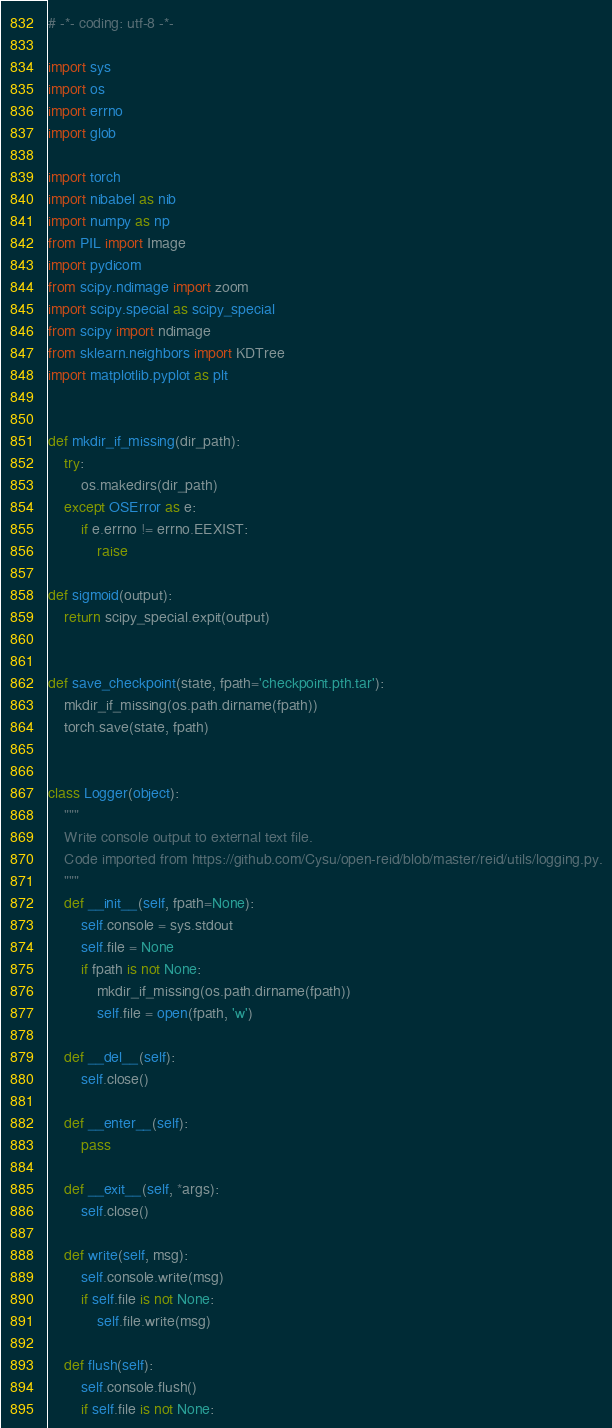Convert code to text. <code><loc_0><loc_0><loc_500><loc_500><_Python_># -*- coding: utf-8 -*-

import sys
import os
import errno
import glob

import torch
import nibabel as nib
import numpy as np
from PIL import Image
import pydicom
from scipy.ndimage import zoom
import scipy.special as scipy_special
from scipy import ndimage
from sklearn.neighbors import KDTree
import matplotlib.pyplot as plt


def mkdir_if_missing(dir_path):
    try:
        os.makedirs(dir_path)
    except OSError as e:
        if e.errno != errno.EEXIST:
            raise

def sigmoid(output):
    return scipy_special.expit(output)


def save_checkpoint(state, fpath='checkpoint.pth.tar'):
    mkdir_if_missing(os.path.dirname(fpath))
    torch.save(state, fpath)


class Logger(object):
    """
    Write console output to external text file.
    Code imported from https://github.com/Cysu/open-reid/blob/master/reid/utils/logging.py.
    """
    def __init__(self, fpath=None):
        self.console = sys.stdout
        self.file = None
        if fpath is not None:
            mkdir_if_missing(os.path.dirname(fpath))
            self.file = open(fpath, 'w')

    def __del__(self):
        self.close()

    def __enter__(self):
        pass

    def __exit__(self, *args):
        self.close()

    def write(self, msg):
        self.console.write(msg)
        if self.file is not None:
            self.file.write(msg)

    def flush(self):
        self.console.flush()
        if self.file is not None:</code> 